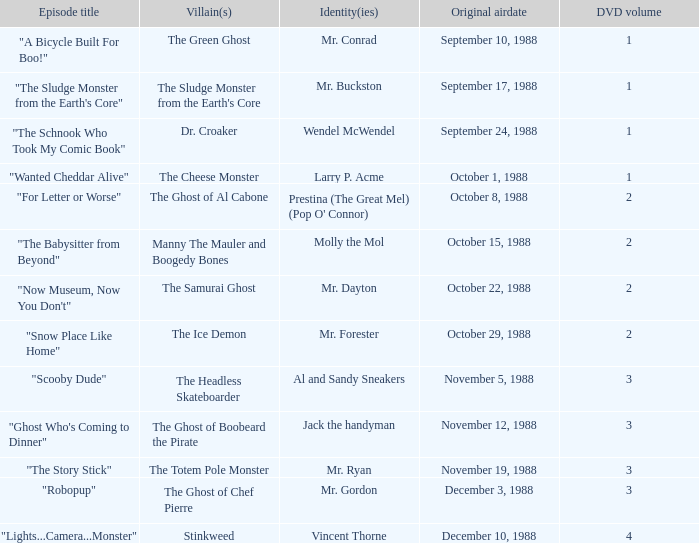Would you mind parsing the complete table? {'header': ['Episode title', 'Villain(s)', 'Identity(ies)', 'Original airdate', 'DVD volume'], 'rows': [['"A Bicycle Built For Boo!"', 'The Green Ghost', 'Mr. Conrad', 'September 10, 1988', '1'], ['"The Sludge Monster from the Earth\'s Core"', "The Sludge Monster from the Earth's Core", 'Mr. Buckston', 'September 17, 1988', '1'], ['"The Schnook Who Took My Comic Book"', 'Dr. Croaker', 'Wendel McWendel', 'September 24, 1988', '1'], ['"Wanted Cheddar Alive"', 'The Cheese Monster', 'Larry P. Acme', 'October 1, 1988', '1'], ['"For Letter or Worse"', 'The Ghost of Al Cabone', "Prestina (The Great Mel) (Pop O' Connor)", 'October 8, 1988', '2'], ['"The Babysitter from Beyond"', 'Manny The Mauler and Boogedy Bones', 'Molly the Mol', 'October 15, 1988', '2'], ['"Now Museum, Now You Don\'t"', 'The Samurai Ghost', 'Mr. Dayton', 'October 22, 1988', '2'], ['"Snow Place Like Home"', 'The Ice Demon', 'Mr. Forester', 'October 29, 1988', '2'], ['"Scooby Dude"', 'The Headless Skateboarder', 'Al and Sandy Sneakers', 'November 5, 1988', '3'], ['"Ghost Who\'s Coming to Dinner"', 'The Ghost of Boobeard the Pirate', 'Jack the handyman', 'November 12, 1988', '3'], ['"The Story Stick"', 'The Totem Pole Monster', 'Mr. Ryan', 'November 19, 1988', '3'], ['"Robopup"', 'The Ghost of Chef Pierre', 'Mr. Gordon', 'December 3, 1988', '3'], ['"Lights...Camera...Monster"', 'Stinkweed', 'Vincent Thorne', 'December 10, 1988', '4']]} Name the original airdate for mr. buckston September 17, 1988. 